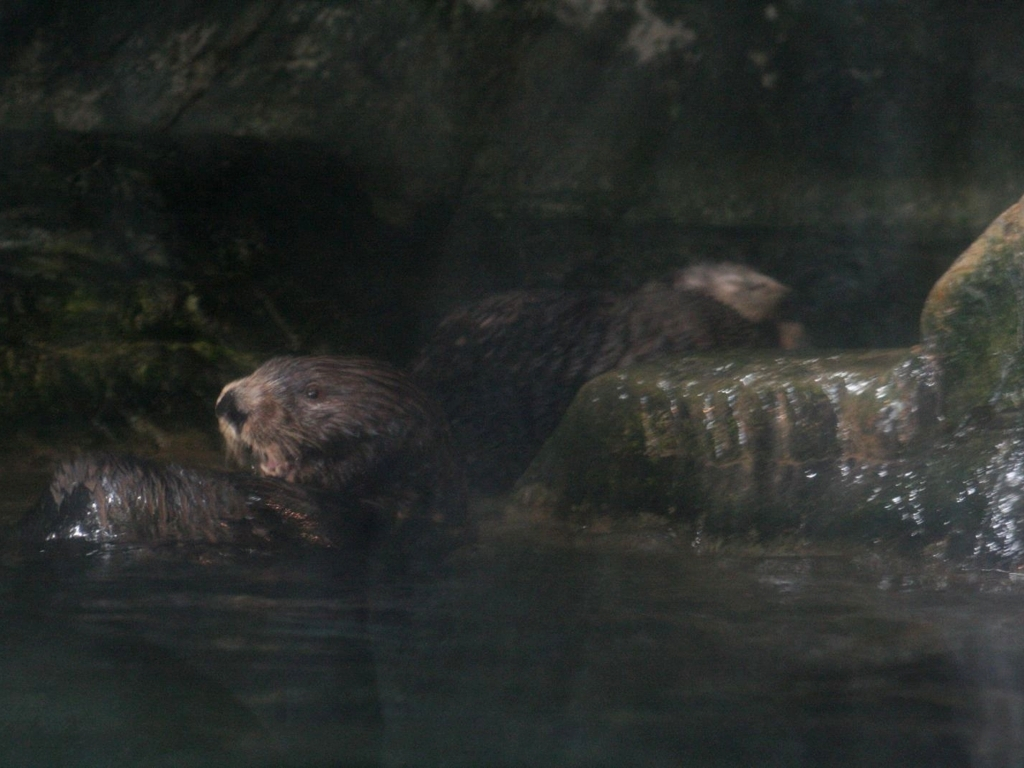Can you describe the environment where these animals are found? The otters are in a watery environment, likely a river, stream, or a zoo habitat. The presence of rocks and possibly vegetation hints at a natural or nature-inspired setting. Do these animals have any notable behaviors? Yes, otters are known for their sociable nature, often seen playing, sliding, and wrestling. They're also skilled hunters, using rocks to crack open prey like shellfish. 